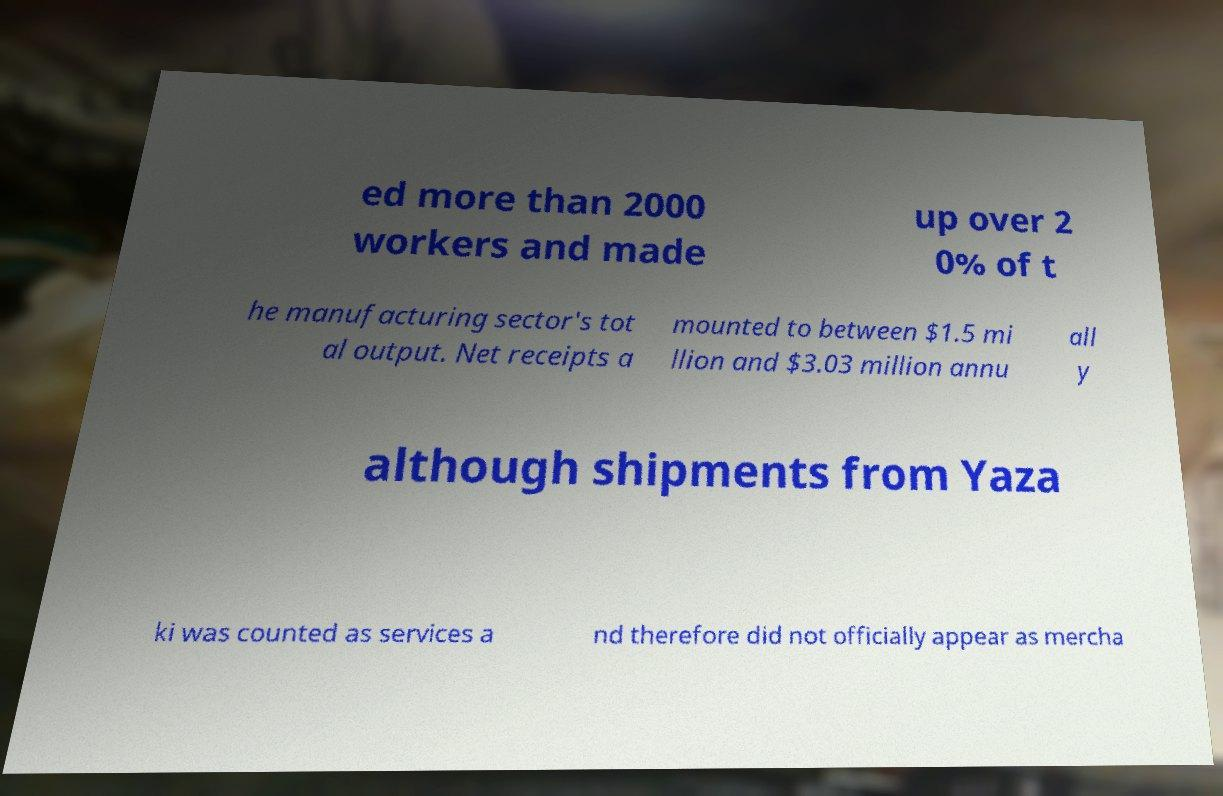Could you assist in decoding the text presented in this image and type it out clearly? ed more than 2000 workers and made up over 2 0% of t he manufacturing sector's tot al output. Net receipts a mounted to between $1.5 mi llion and $3.03 million annu all y although shipments from Yaza ki was counted as services a nd therefore did not officially appear as mercha 